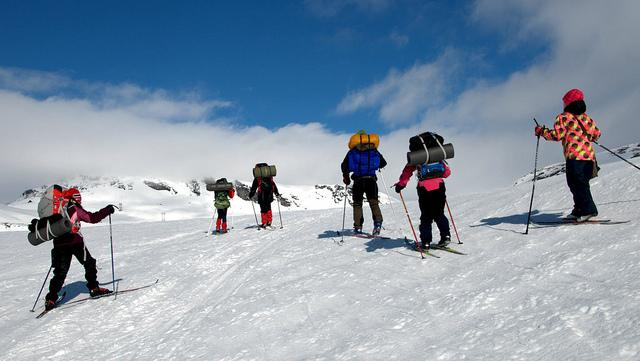Where are they going? Please explain your reasoning. uphill. The people are climbing up higher or uphill. 